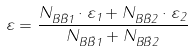<formula> <loc_0><loc_0><loc_500><loc_500>\varepsilon = \frac { N _ { B \bar { B } 1 } \cdot \varepsilon _ { 1 } + N _ { B \bar { B } 2 } \cdot \varepsilon _ { 2 } } { N _ { B \bar { B } 1 } + N _ { B \bar { B } 2 } }</formula> 